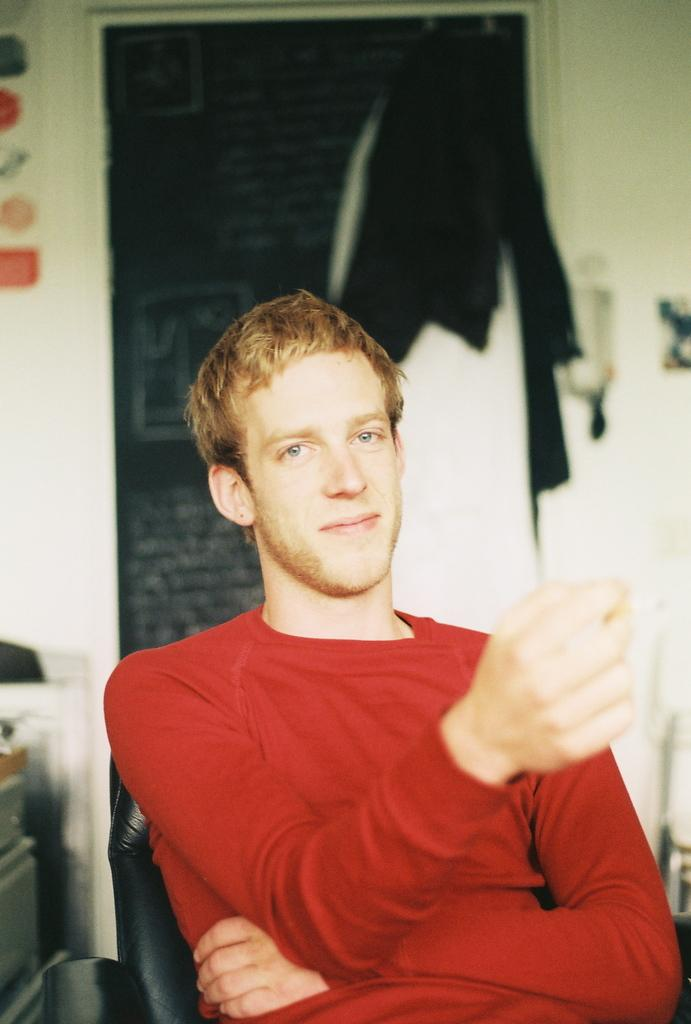What is the person in the image doing? The person is sitting on a chair in the image. What is the person wearing? The person is wearing a red dress. What can be seen in the background of the image? There are clothes and a wall visible in the background of the image. What type of clouds can be seen in the image? There are no clouds visible in the image. 